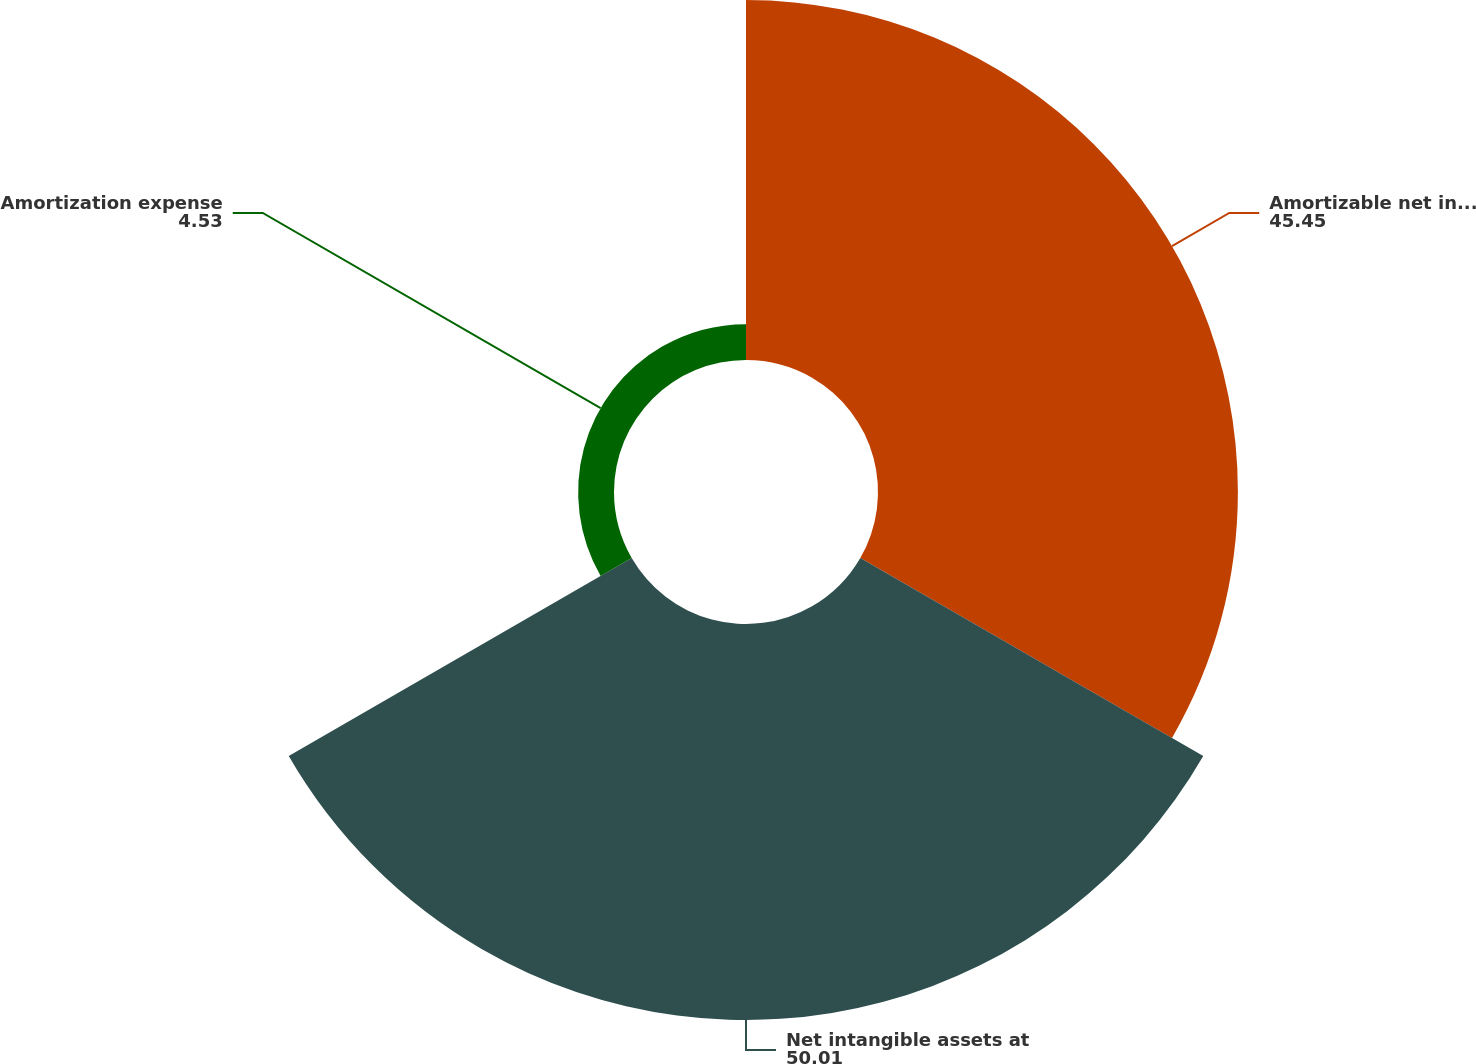<chart> <loc_0><loc_0><loc_500><loc_500><pie_chart><fcel>Amortizable net intangible<fcel>Net intangible assets at<fcel>Amortization expense<nl><fcel>45.45%<fcel>50.01%<fcel>4.53%<nl></chart> 